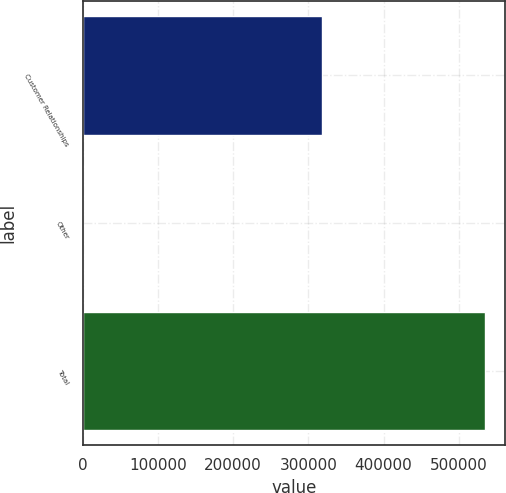Convert chart to OTSL. <chart><loc_0><loc_0><loc_500><loc_500><bar_chart><fcel>Customer Relationships<fcel>Other<fcel>Total<nl><fcel>317593<fcel>706<fcel>534572<nl></chart> 